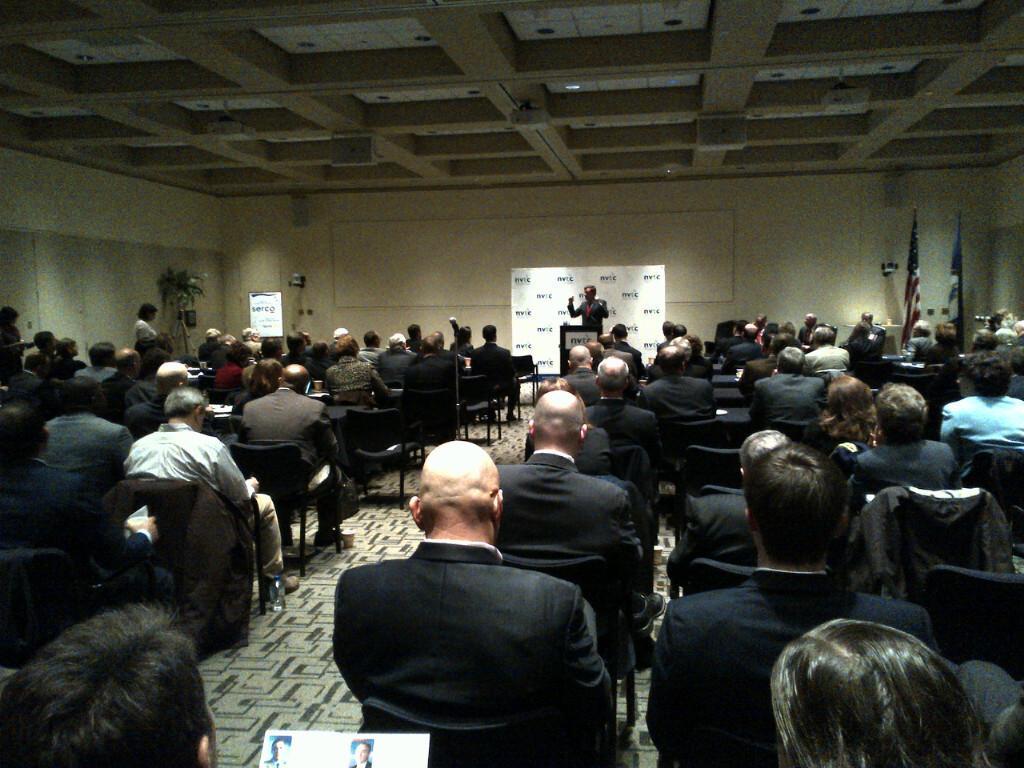Describe this image in one or two sentences. In this image there are people sitting on chairs, in the background there is a man standing in front of a podium and there is a wall, near the wall there are flags, at the top there is a ceiling. 